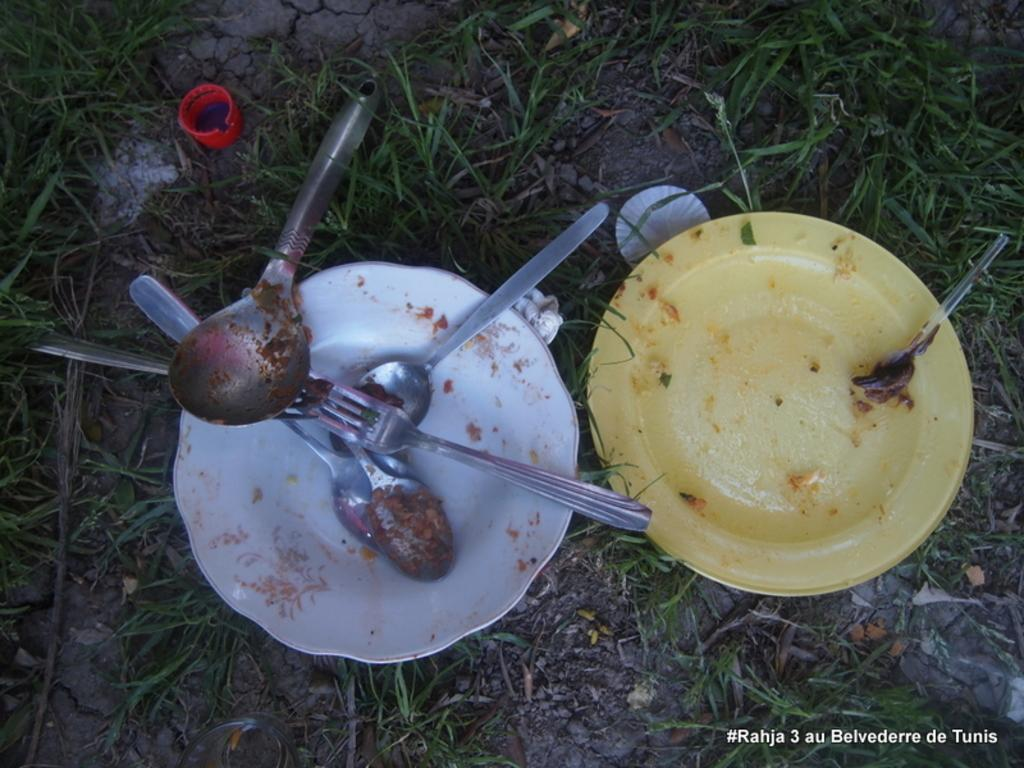What type of utensils can be seen in the image? There are forks and spoons in the image. What is used for serving food in the image? There are plates in the image. What type of natural environment is visible in the image? The grass is visible in the image. What other objects can be seen in the image besides utensils and plates? There are other objects present in the image. Can you tell me how many squirrels are playing with the locket in the image? There are no squirrels or lockets present in the image. 